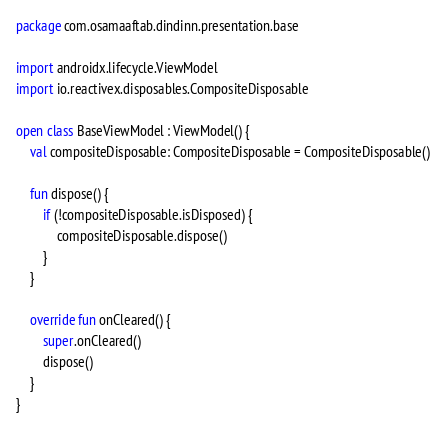<code> <loc_0><loc_0><loc_500><loc_500><_Kotlin_>package com.osamaaftab.dindinn.presentation.base

import androidx.lifecycle.ViewModel
import io.reactivex.disposables.CompositeDisposable

open class BaseViewModel : ViewModel() {
    val compositeDisposable: CompositeDisposable = CompositeDisposable()

    fun dispose() {
        if (!compositeDisposable.isDisposed) {
            compositeDisposable.dispose()
        }
    }

    override fun onCleared() {
        super.onCleared()
        dispose()
    }
}</code> 